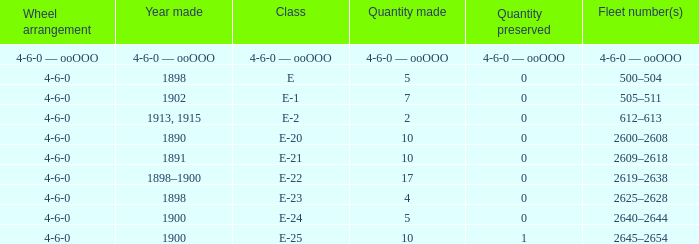What is the quantity made of the e-22 class, which has a quantity preserved of 0? 17.0. Can you parse all the data within this table? {'header': ['Wheel arrangement', 'Year made', 'Class', 'Quantity made', 'Quantity preserved', 'Fleet number(s)'], 'rows': [['4-6-0 — ooOOO', '4-6-0 — ooOOO', '4-6-0 — ooOOO', '4-6-0 — ooOOO', '4-6-0 — ooOOO', '4-6-0 — ooOOO'], ['4-6-0', '1898', 'E', '5', '0', '500–504'], ['4-6-0', '1902', 'E-1', '7', '0', '505–511'], ['4-6-0', '1913, 1915', 'E-2', '2', '0', '612–613'], ['4-6-0', '1890', 'E-20', '10', '0', '2600–2608'], ['4-6-0', '1891', 'E-21', '10', '0', '2609–2618'], ['4-6-0', '1898–1900', 'E-22', '17', '0', '2619–2638'], ['4-6-0', '1898', 'E-23', '4', '0', '2625–2628'], ['4-6-0', '1900', 'E-24', '5', '0', '2640–2644'], ['4-6-0', '1900', 'E-25', '10', '1', '2645–2654']]} 